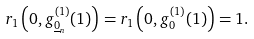<formula> <loc_0><loc_0><loc_500><loc_500>r _ { 1 } \left ( 0 , g _ { \underline { 0 } _ { n } } ^ { ( 1 ) } ( 1 ) \right ) = r _ { 1 } \left ( 0 , g _ { 0 } ^ { ( 1 ) } ( 1 ) \right ) = 1 .</formula> 